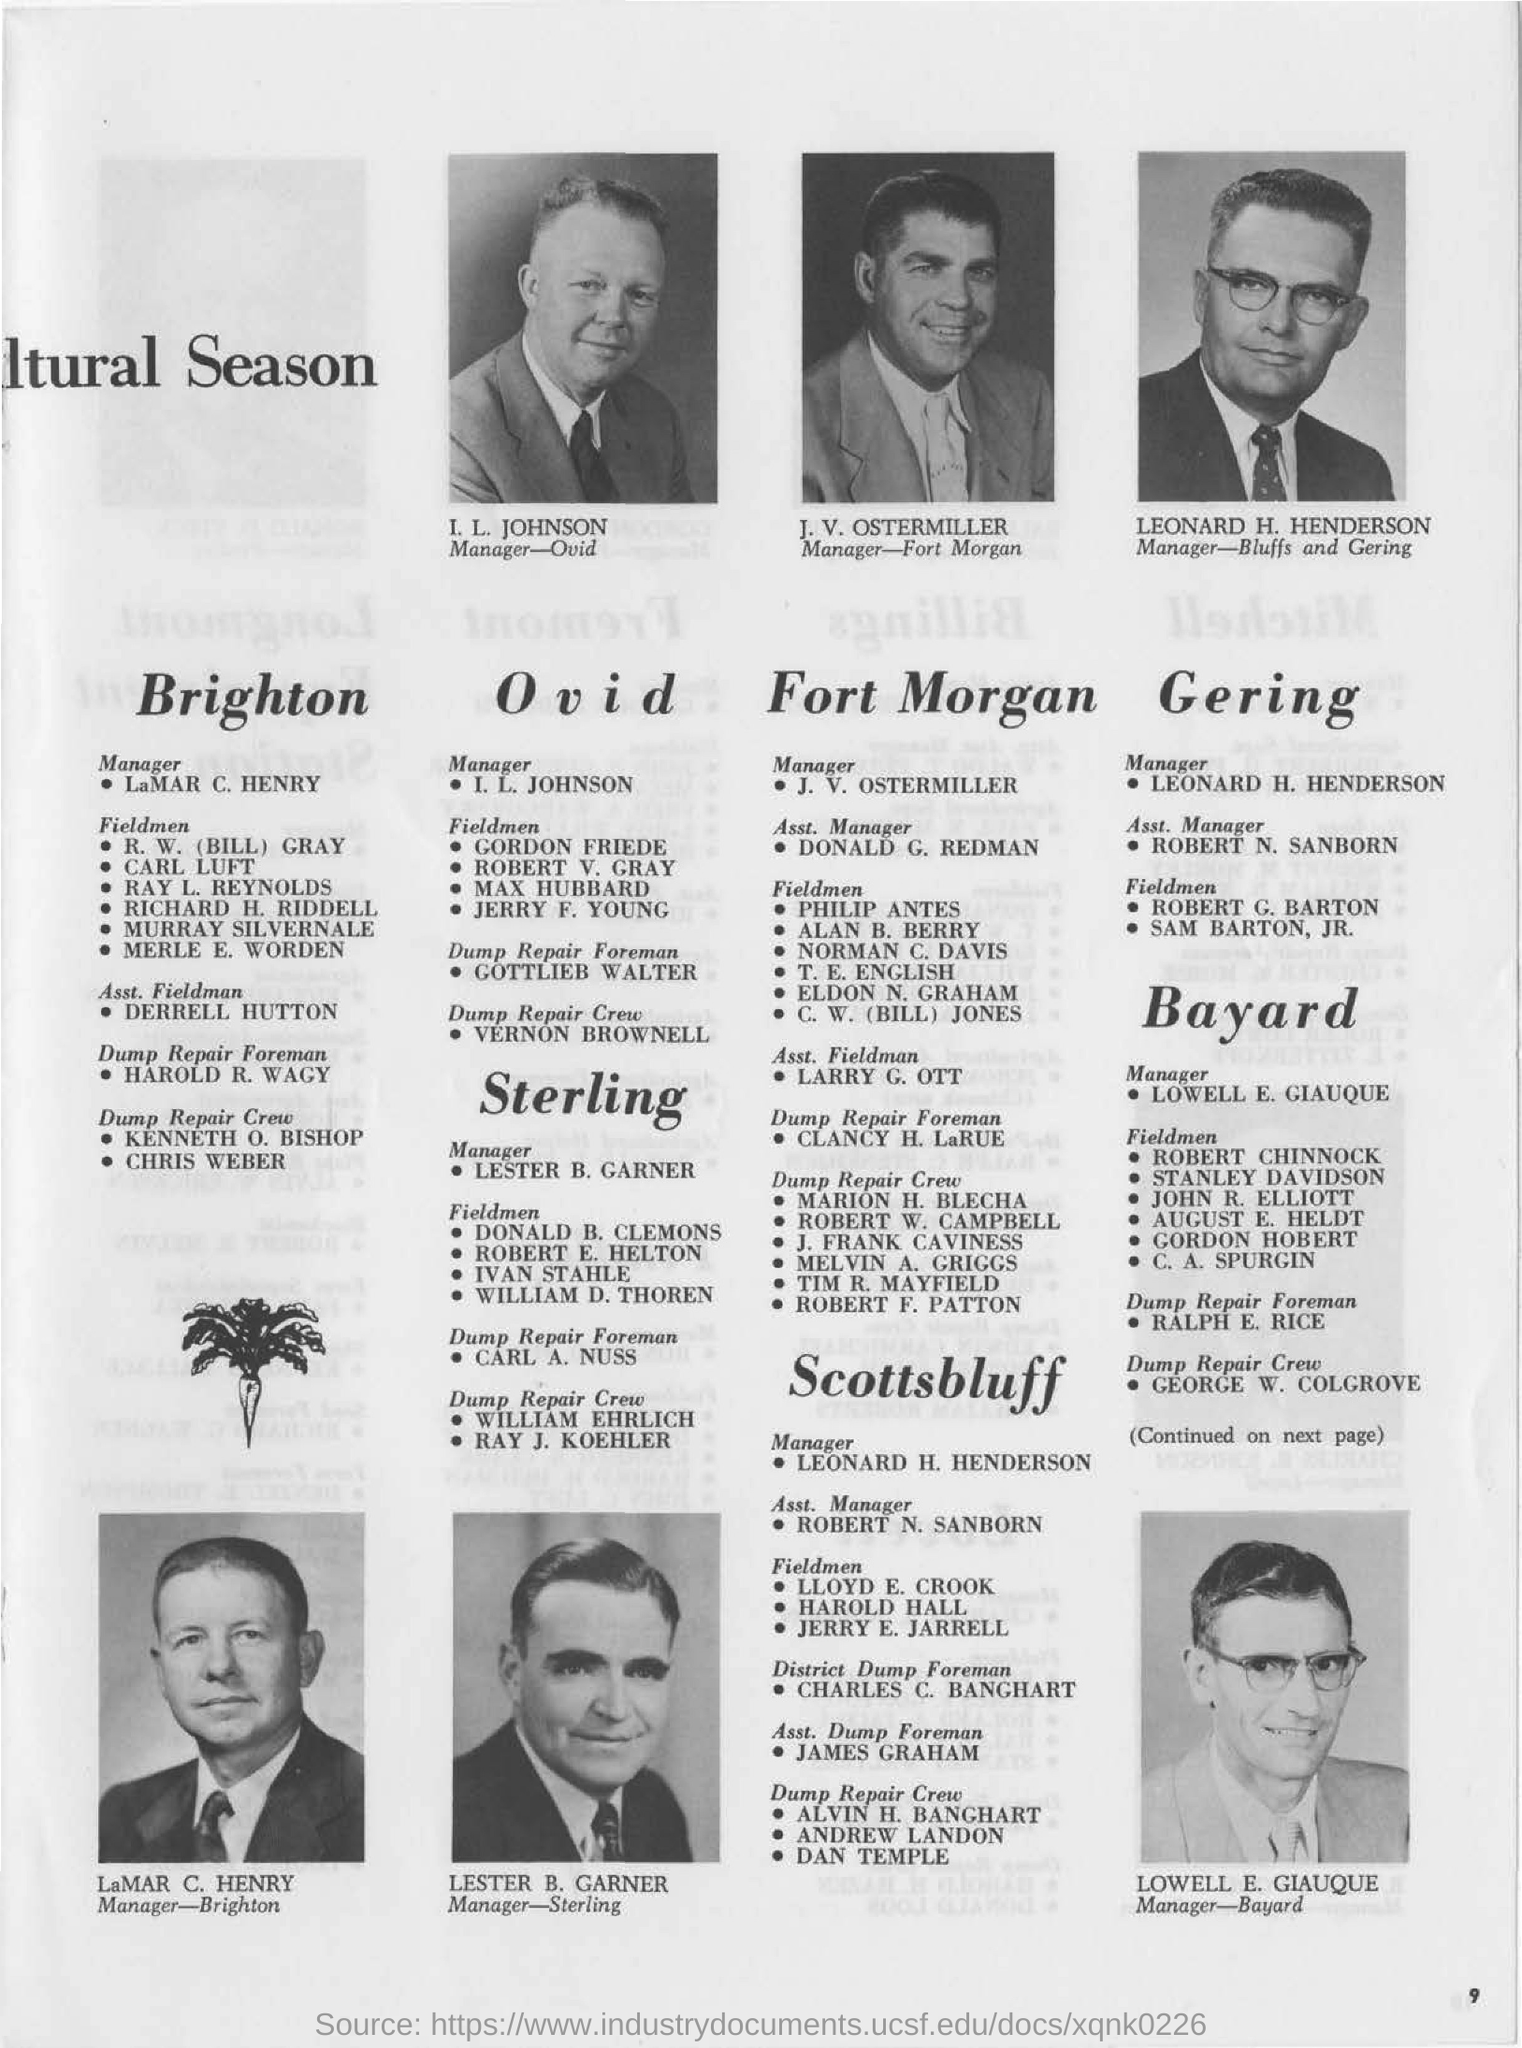Identify some key points in this picture. The individual named I. L. Johnson is the manager for OVID. Lester B. Garner is the manager for Sterling. 